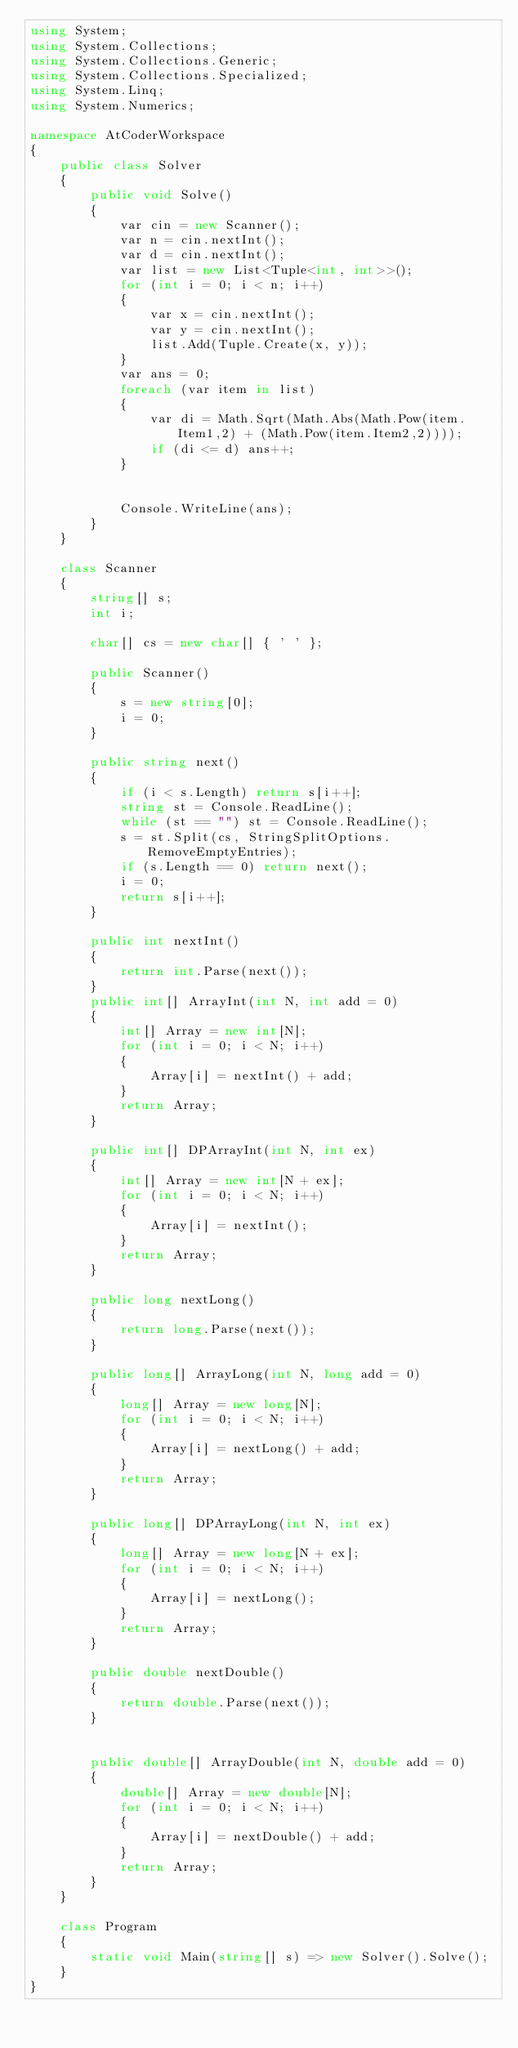<code> <loc_0><loc_0><loc_500><loc_500><_C#_>using System;
using System.Collections;
using System.Collections.Generic;
using System.Collections.Specialized;
using System.Linq;
using System.Numerics;

namespace AtCoderWorkspace
{
    public class Solver
    {
        public void Solve()
        {
            var cin = new Scanner();
            var n = cin.nextInt();
            var d = cin.nextInt();
            var list = new List<Tuple<int, int>>();
            for (int i = 0; i < n; i++)
            {
                var x = cin.nextInt();
                var y = cin.nextInt();
                list.Add(Tuple.Create(x, y));
            }
            var ans = 0;
            foreach (var item in list)
            {
                var di = Math.Sqrt(Math.Abs(Math.Pow(item.Item1,2) + (Math.Pow(item.Item2,2))));
                if (di <= d) ans++;
            }


            Console.WriteLine(ans);
        }
    }

    class Scanner
    {
        string[] s;
        int i;

        char[] cs = new char[] { ' ' };

        public Scanner()
        {
            s = new string[0];
            i = 0;
        }

        public string next()
        {
            if (i < s.Length) return s[i++];
            string st = Console.ReadLine();
            while (st == "") st = Console.ReadLine();
            s = st.Split(cs, StringSplitOptions.RemoveEmptyEntries);
            if (s.Length == 0) return next();
            i = 0;
            return s[i++];
        }

        public int nextInt()
        {
            return int.Parse(next());
        }
        public int[] ArrayInt(int N, int add = 0)
        {
            int[] Array = new int[N];
            for (int i = 0; i < N; i++)
            {
                Array[i] = nextInt() + add;
            }
            return Array;
        }

        public int[] DPArrayInt(int N, int ex)
        {
            int[] Array = new int[N + ex];
            for (int i = 0; i < N; i++)
            {
                Array[i] = nextInt();
            }
            return Array;
        }

        public long nextLong()
        {
            return long.Parse(next());
        }

        public long[] ArrayLong(int N, long add = 0)
        {
            long[] Array = new long[N];
            for (int i = 0; i < N; i++)
            {
                Array[i] = nextLong() + add;
            }
            return Array;
        }

        public long[] DPArrayLong(int N, int ex)
        {
            long[] Array = new long[N + ex];
            for (int i = 0; i < N; i++)
            {
                Array[i] = nextLong();
            }
            return Array;
        }

        public double nextDouble()
        {
            return double.Parse(next());
        }


        public double[] ArrayDouble(int N, double add = 0)
        {
            double[] Array = new double[N];
            for (int i = 0; i < N; i++)
            {
                Array[i] = nextDouble() + add;
            }
            return Array;
        }
    }

    class Program
    {
        static void Main(string[] s) => new Solver().Solve();
    }
}
</code> 